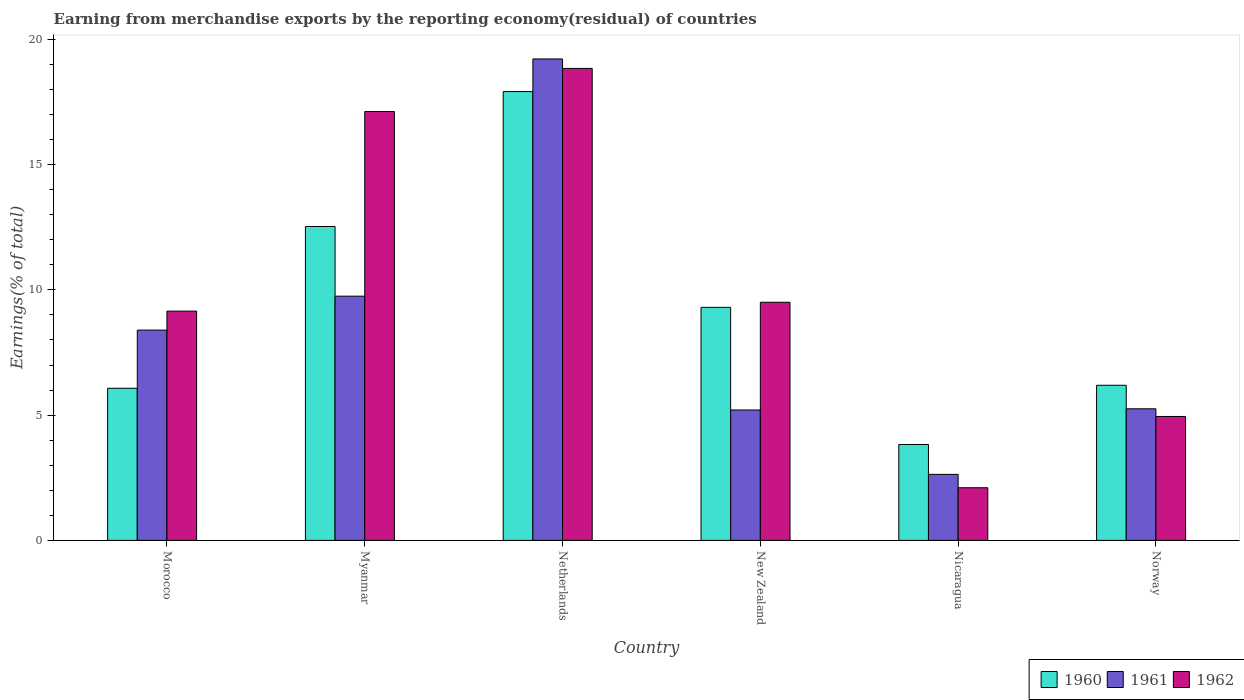How many different coloured bars are there?
Provide a succinct answer. 3. Are the number of bars per tick equal to the number of legend labels?
Make the answer very short. Yes. Are the number of bars on each tick of the X-axis equal?
Provide a succinct answer. Yes. How many bars are there on the 5th tick from the left?
Keep it short and to the point. 3. How many bars are there on the 2nd tick from the right?
Make the answer very short. 3. What is the label of the 2nd group of bars from the left?
Provide a succinct answer. Myanmar. In how many cases, is the number of bars for a given country not equal to the number of legend labels?
Your response must be concise. 0. What is the percentage of amount earned from merchandise exports in 1961 in Nicaragua?
Offer a very short reply. 2.64. Across all countries, what is the maximum percentage of amount earned from merchandise exports in 1960?
Offer a terse response. 17.91. Across all countries, what is the minimum percentage of amount earned from merchandise exports in 1961?
Your answer should be very brief. 2.64. In which country was the percentage of amount earned from merchandise exports in 1961 maximum?
Your answer should be compact. Netherlands. In which country was the percentage of amount earned from merchandise exports in 1960 minimum?
Keep it short and to the point. Nicaragua. What is the total percentage of amount earned from merchandise exports in 1961 in the graph?
Make the answer very short. 50.45. What is the difference between the percentage of amount earned from merchandise exports in 1962 in New Zealand and that in Norway?
Your answer should be compact. 4.56. What is the difference between the percentage of amount earned from merchandise exports in 1962 in Myanmar and the percentage of amount earned from merchandise exports in 1961 in Nicaragua?
Provide a succinct answer. 14.48. What is the average percentage of amount earned from merchandise exports in 1961 per country?
Your answer should be compact. 8.41. What is the difference between the percentage of amount earned from merchandise exports of/in 1960 and percentage of amount earned from merchandise exports of/in 1962 in Netherlands?
Keep it short and to the point. -0.92. In how many countries, is the percentage of amount earned from merchandise exports in 1960 greater than 6 %?
Your answer should be compact. 5. What is the ratio of the percentage of amount earned from merchandise exports in 1962 in Morocco to that in New Zealand?
Make the answer very short. 0.96. What is the difference between the highest and the second highest percentage of amount earned from merchandise exports in 1960?
Your answer should be compact. 5.39. What is the difference between the highest and the lowest percentage of amount earned from merchandise exports in 1961?
Give a very brief answer. 16.58. What does the 2nd bar from the left in Nicaragua represents?
Your answer should be compact. 1961. What does the 3rd bar from the right in Morocco represents?
Your response must be concise. 1960. Is it the case that in every country, the sum of the percentage of amount earned from merchandise exports in 1961 and percentage of amount earned from merchandise exports in 1960 is greater than the percentage of amount earned from merchandise exports in 1962?
Keep it short and to the point. Yes. How many bars are there?
Offer a very short reply. 18. Are all the bars in the graph horizontal?
Make the answer very short. No. What is the difference between two consecutive major ticks on the Y-axis?
Provide a succinct answer. 5. Does the graph contain any zero values?
Your response must be concise. No. Does the graph contain grids?
Your answer should be compact. No. Where does the legend appear in the graph?
Your answer should be compact. Bottom right. How many legend labels are there?
Provide a succinct answer. 3. How are the legend labels stacked?
Offer a very short reply. Horizontal. What is the title of the graph?
Provide a short and direct response. Earning from merchandise exports by the reporting economy(residual) of countries. Does "2000" appear as one of the legend labels in the graph?
Make the answer very short. No. What is the label or title of the Y-axis?
Offer a very short reply. Earnings(% of total). What is the Earnings(% of total) in 1960 in Morocco?
Give a very brief answer. 6.07. What is the Earnings(% of total) of 1961 in Morocco?
Provide a succinct answer. 8.39. What is the Earnings(% of total) in 1962 in Morocco?
Provide a succinct answer. 9.15. What is the Earnings(% of total) of 1960 in Myanmar?
Offer a very short reply. 12.53. What is the Earnings(% of total) in 1961 in Myanmar?
Offer a terse response. 9.75. What is the Earnings(% of total) of 1962 in Myanmar?
Offer a terse response. 17.12. What is the Earnings(% of total) of 1960 in Netherlands?
Give a very brief answer. 17.91. What is the Earnings(% of total) of 1961 in Netherlands?
Offer a very short reply. 19.22. What is the Earnings(% of total) in 1962 in Netherlands?
Your answer should be compact. 18.84. What is the Earnings(% of total) of 1960 in New Zealand?
Give a very brief answer. 9.3. What is the Earnings(% of total) of 1961 in New Zealand?
Your answer should be compact. 5.21. What is the Earnings(% of total) in 1962 in New Zealand?
Offer a terse response. 9.51. What is the Earnings(% of total) in 1960 in Nicaragua?
Your answer should be very brief. 3.83. What is the Earnings(% of total) in 1961 in Nicaragua?
Give a very brief answer. 2.64. What is the Earnings(% of total) in 1962 in Nicaragua?
Make the answer very short. 2.1. What is the Earnings(% of total) in 1960 in Norway?
Offer a very short reply. 6.19. What is the Earnings(% of total) in 1961 in Norway?
Offer a very short reply. 5.25. What is the Earnings(% of total) of 1962 in Norway?
Your response must be concise. 4.95. Across all countries, what is the maximum Earnings(% of total) of 1960?
Your answer should be compact. 17.91. Across all countries, what is the maximum Earnings(% of total) of 1961?
Give a very brief answer. 19.22. Across all countries, what is the maximum Earnings(% of total) of 1962?
Provide a short and direct response. 18.84. Across all countries, what is the minimum Earnings(% of total) of 1960?
Offer a very short reply. 3.83. Across all countries, what is the minimum Earnings(% of total) of 1961?
Offer a terse response. 2.64. Across all countries, what is the minimum Earnings(% of total) of 1962?
Offer a terse response. 2.1. What is the total Earnings(% of total) in 1960 in the graph?
Your answer should be compact. 55.84. What is the total Earnings(% of total) in 1961 in the graph?
Make the answer very short. 50.45. What is the total Earnings(% of total) of 1962 in the graph?
Provide a succinct answer. 61.66. What is the difference between the Earnings(% of total) of 1960 in Morocco and that in Myanmar?
Offer a terse response. -6.46. What is the difference between the Earnings(% of total) of 1961 in Morocco and that in Myanmar?
Provide a succinct answer. -1.35. What is the difference between the Earnings(% of total) of 1962 in Morocco and that in Myanmar?
Offer a terse response. -7.97. What is the difference between the Earnings(% of total) in 1960 in Morocco and that in Netherlands?
Provide a short and direct response. -11.84. What is the difference between the Earnings(% of total) in 1961 in Morocco and that in Netherlands?
Provide a short and direct response. -10.82. What is the difference between the Earnings(% of total) in 1962 in Morocco and that in Netherlands?
Offer a terse response. -9.69. What is the difference between the Earnings(% of total) in 1960 in Morocco and that in New Zealand?
Your response must be concise. -3.23. What is the difference between the Earnings(% of total) in 1961 in Morocco and that in New Zealand?
Ensure brevity in your answer.  3.19. What is the difference between the Earnings(% of total) of 1962 in Morocco and that in New Zealand?
Ensure brevity in your answer.  -0.35. What is the difference between the Earnings(% of total) in 1960 in Morocco and that in Nicaragua?
Make the answer very short. 2.24. What is the difference between the Earnings(% of total) of 1961 in Morocco and that in Nicaragua?
Your answer should be very brief. 5.76. What is the difference between the Earnings(% of total) of 1962 in Morocco and that in Nicaragua?
Your answer should be very brief. 7.05. What is the difference between the Earnings(% of total) in 1960 in Morocco and that in Norway?
Your answer should be very brief. -0.12. What is the difference between the Earnings(% of total) of 1961 in Morocco and that in Norway?
Your answer should be very brief. 3.14. What is the difference between the Earnings(% of total) of 1962 in Morocco and that in Norway?
Offer a terse response. 4.21. What is the difference between the Earnings(% of total) in 1960 in Myanmar and that in Netherlands?
Give a very brief answer. -5.39. What is the difference between the Earnings(% of total) of 1961 in Myanmar and that in Netherlands?
Keep it short and to the point. -9.47. What is the difference between the Earnings(% of total) in 1962 in Myanmar and that in Netherlands?
Offer a very short reply. -1.72. What is the difference between the Earnings(% of total) of 1960 in Myanmar and that in New Zealand?
Give a very brief answer. 3.23. What is the difference between the Earnings(% of total) in 1961 in Myanmar and that in New Zealand?
Provide a short and direct response. 4.54. What is the difference between the Earnings(% of total) of 1962 in Myanmar and that in New Zealand?
Ensure brevity in your answer.  7.61. What is the difference between the Earnings(% of total) in 1960 in Myanmar and that in Nicaragua?
Give a very brief answer. 8.7. What is the difference between the Earnings(% of total) in 1961 in Myanmar and that in Nicaragua?
Ensure brevity in your answer.  7.11. What is the difference between the Earnings(% of total) in 1962 in Myanmar and that in Nicaragua?
Ensure brevity in your answer.  15.02. What is the difference between the Earnings(% of total) of 1960 in Myanmar and that in Norway?
Provide a succinct answer. 6.34. What is the difference between the Earnings(% of total) of 1961 in Myanmar and that in Norway?
Provide a succinct answer. 4.5. What is the difference between the Earnings(% of total) in 1962 in Myanmar and that in Norway?
Keep it short and to the point. 12.17. What is the difference between the Earnings(% of total) of 1960 in Netherlands and that in New Zealand?
Provide a short and direct response. 8.61. What is the difference between the Earnings(% of total) of 1961 in Netherlands and that in New Zealand?
Offer a very short reply. 14.01. What is the difference between the Earnings(% of total) in 1962 in Netherlands and that in New Zealand?
Make the answer very short. 9.33. What is the difference between the Earnings(% of total) in 1960 in Netherlands and that in Nicaragua?
Your answer should be very brief. 14.09. What is the difference between the Earnings(% of total) of 1961 in Netherlands and that in Nicaragua?
Ensure brevity in your answer.  16.58. What is the difference between the Earnings(% of total) in 1962 in Netherlands and that in Nicaragua?
Your answer should be very brief. 16.74. What is the difference between the Earnings(% of total) in 1960 in Netherlands and that in Norway?
Your answer should be compact. 11.72. What is the difference between the Earnings(% of total) of 1961 in Netherlands and that in Norway?
Your response must be concise. 13.96. What is the difference between the Earnings(% of total) of 1962 in Netherlands and that in Norway?
Provide a succinct answer. 13.89. What is the difference between the Earnings(% of total) of 1960 in New Zealand and that in Nicaragua?
Give a very brief answer. 5.48. What is the difference between the Earnings(% of total) of 1961 in New Zealand and that in Nicaragua?
Your answer should be very brief. 2.57. What is the difference between the Earnings(% of total) of 1962 in New Zealand and that in Nicaragua?
Give a very brief answer. 7.4. What is the difference between the Earnings(% of total) of 1960 in New Zealand and that in Norway?
Give a very brief answer. 3.11. What is the difference between the Earnings(% of total) of 1961 in New Zealand and that in Norway?
Your answer should be compact. -0.05. What is the difference between the Earnings(% of total) of 1962 in New Zealand and that in Norway?
Your answer should be very brief. 4.56. What is the difference between the Earnings(% of total) in 1960 in Nicaragua and that in Norway?
Ensure brevity in your answer.  -2.36. What is the difference between the Earnings(% of total) of 1961 in Nicaragua and that in Norway?
Provide a succinct answer. -2.62. What is the difference between the Earnings(% of total) of 1962 in Nicaragua and that in Norway?
Provide a succinct answer. -2.84. What is the difference between the Earnings(% of total) in 1960 in Morocco and the Earnings(% of total) in 1961 in Myanmar?
Keep it short and to the point. -3.68. What is the difference between the Earnings(% of total) in 1960 in Morocco and the Earnings(% of total) in 1962 in Myanmar?
Provide a short and direct response. -11.05. What is the difference between the Earnings(% of total) of 1961 in Morocco and the Earnings(% of total) of 1962 in Myanmar?
Ensure brevity in your answer.  -8.72. What is the difference between the Earnings(% of total) in 1960 in Morocco and the Earnings(% of total) in 1961 in Netherlands?
Ensure brevity in your answer.  -13.14. What is the difference between the Earnings(% of total) in 1960 in Morocco and the Earnings(% of total) in 1962 in Netherlands?
Keep it short and to the point. -12.77. What is the difference between the Earnings(% of total) of 1961 in Morocco and the Earnings(% of total) of 1962 in Netherlands?
Your answer should be compact. -10.45. What is the difference between the Earnings(% of total) of 1960 in Morocco and the Earnings(% of total) of 1961 in New Zealand?
Your answer should be compact. 0.87. What is the difference between the Earnings(% of total) of 1960 in Morocco and the Earnings(% of total) of 1962 in New Zealand?
Your response must be concise. -3.43. What is the difference between the Earnings(% of total) in 1961 in Morocco and the Earnings(% of total) in 1962 in New Zealand?
Give a very brief answer. -1.11. What is the difference between the Earnings(% of total) in 1960 in Morocco and the Earnings(% of total) in 1961 in Nicaragua?
Your response must be concise. 3.44. What is the difference between the Earnings(% of total) of 1960 in Morocco and the Earnings(% of total) of 1962 in Nicaragua?
Your response must be concise. 3.97. What is the difference between the Earnings(% of total) of 1961 in Morocco and the Earnings(% of total) of 1962 in Nicaragua?
Your answer should be very brief. 6.29. What is the difference between the Earnings(% of total) in 1960 in Morocco and the Earnings(% of total) in 1961 in Norway?
Offer a very short reply. 0.82. What is the difference between the Earnings(% of total) of 1960 in Morocco and the Earnings(% of total) of 1962 in Norway?
Your answer should be compact. 1.13. What is the difference between the Earnings(% of total) of 1961 in Morocco and the Earnings(% of total) of 1962 in Norway?
Ensure brevity in your answer.  3.45. What is the difference between the Earnings(% of total) in 1960 in Myanmar and the Earnings(% of total) in 1961 in Netherlands?
Give a very brief answer. -6.69. What is the difference between the Earnings(% of total) in 1960 in Myanmar and the Earnings(% of total) in 1962 in Netherlands?
Keep it short and to the point. -6.31. What is the difference between the Earnings(% of total) of 1961 in Myanmar and the Earnings(% of total) of 1962 in Netherlands?
Offer a very short reply. -9.09. What is the difference between the Earnings(% of total) in 1960 in Myanmar and the Earnings(% of total) in 1961 in New Zealand?
Give a very brief answer. 7.32. What is the difference between the Earnings(% of total) of 1960 in Myanmar and the Earnings(% of total) of 1962 in New Zealand?
Ensure brevity in your answer.  3.02. What is the difference between the Earnings(% of total) of 1961 in Myanmar and the Earnings(% of total) of 1962 in New Zealand?
Your answer should be very brief. 0.24. What is the difference between the Earnings(% of total) of 1960 in Myanmar and the Earnings(% of total) of 1961 in Nicaragua?
Ensure brevity in your answer.  9.89. What is the difference between the Earnings(% of total) of 1960 in Myanmar and the Earnings(% of total) of 1962 in Nicaragua?
Ensure brevity in your answer.  10.43. What is the difference between the Earnings(% of total) of 1961 in Myanmar and the Earnings(% of total) of 1962 in Nicaragua?
Make the answer very short. 7.65. What is the difference between the Earnings(% of total) of 1960 in Myanmar and the Earnings(% of total) of 1961 in Norway?
Keep it short and to the point. 7.28. What is the difference between the Earnings(% of total) of 1960 in Myanmar and the Earnings(% of total) of 1962 in Norway?
Ensure brevity in your answer.  7.58. What is the difference between the Earnings(% of total) of 1961 in Myanmar and the Earnings(% of total) of 1962 in Norway?
Provide a succinct answer. 4.8. What is the difference between the Earnings(% of total) in 1960 in Netherlands and the Earnings(% of total) in 1961 in New Zealand?
Keep it short and to the point. 12.71. What is the difference between the Earnings(% of total) in 1960 in Netherlands and the Earnings(% of total) in 1962 in New Zealand?
Offer a terse response. 8.41. What is the difference between the Earnings(% of total) of 1961 in Netherlands and the Earnings(% of total) of 1962 in New Zealand?
Keep it short and to the point. 9.71. What is the difference between the Earnings(% of total) in 1960 in Netherlands and the Earnings(% of total) in 1961 in Nicaragua?
Your answer should be very brief. 15.28. What is the difference between the Earnings(% of total) in 1960 in Netherlands and the Earnings(% of total) in 1962 in Nicaragua?
Provide a short and direct response. 15.81. What is the difference between the Earnings(% of total) of 1961 in Netherlands and the Earnings(% of total) of 1962 in Nicaragua?
Provide a short and direct response. 17.12. What is the difference between the Earnings(% of total) in 1960 in Netherlands and the Earnings(% of total) in 1961 in Norway?
Provide a short and direct response. 12.66. What is the difference between the Earnings(% of total) in 1960 in Netherlands and the Earnings(% of total) in 1962 in Norway?
Your answer should be very brief. 12.97. What is the difference between the Earnings(% of total) of 1961 in Netherlands and the Earnings(% of total) of 1962 in Norway?
Provide a succinct answer. 14.27. What is the difference between the Earnings(% of total) of 1960 in New Zealand and the Earnings(% of total) of 1961 in Nicaragua?
Offer a terse response. 6.67. What is the difference between the Earnings(% of total) of 1960 in New Zealand and the Earnings(% of total) of 1962 in Nicaragua?
Keep it short and to the point. 7.2. What is the difference between the Earnings(% of total) of 1961 in New Zealand and the Earnings(% of total) of 1962 in Nicaragua?
Your response must be concise. 3.1. What is the difference between the Earnings(% of total) in 1960 in New Zealand and the Earnings(% of total) in 1961 in Norway?
Offer a terse response. 4.05. What is the difference between the Earnings(% of total) of 1960 in New Zealand and the Earnings(% of total) of 1962 in Norway?
Provide a succinct answer. 4.36. What is the difference between the Earnings(% of total) in 1961 in New Zealand and the Earnings(% of total) in 1962 in Norway?
Give a very brief answer. 0.26. What is the difference between the Earnings(% of total) in 1960 in Nicaragua and the Earnings(% of total) in 1961 in Norway?
Make the answer very short. -1.42. What is the difference between the Earnings(% of total) in 1960 in Nicaragua and the Earnings(% of total) in 1962 in Norway?
Offer a terse response. -1.12. What is the difference between the Earnings(% of total) in 1961 in Nicaragua and the Earnings(% of total) in 1962 in Norway?
Provide a short and direct response. -2.31. What is the average Earnings(% of total) of 1960 per country?
Your answer should be compact. 9.31. What is the average Earnings(% of total) in 1961 per country?
Provide a succinct answer. 8.41. What is the average Earnings(% of total) in 1962 per country?
Make the answer very short. 10.28. What is the difference between the Earnings(% of total) in 1960 and Earnings(% of total) in 1961 in Morocco?
Provide a succinct answer. -2.32. What is the difference between the Earnings(% of total) of 1960 and Earnings(% of total) of 1962 in Morocco?
Your response must be concise. -3.08. What is the difference between the Earnings(% of total) in 1961 and Earnings(% of total) in 1962 in Morocco?
Offer a terse response. -0.76. What is the difference between the Earnings(% of total) of 1960 and Earnings(% of total) of 1961 in Myanmar?
Provide a succinct answer. 2.78. What is the difference between the Earnings(% of total) of 1960 and Earnings(% of total) of 1962 in Myanmar?
Provide a succinct answer. -4.59. What is the difference between the Earnings(% of total) in 1961 and Earnings(% of total) in 1962 in Myanmar?
Provide a short and direct response. -7.37. What is the difference between the Earnings(% of total) in 1960 and Earnings(% of total) in 1961 in Netherlands?
Your answer should be compact. -1.3. What is the difference between the Earnings(% of total) in 1960 and Earnings(% of total) in 1962 in Netherlands?
Offer a very short reply. -0.92. What is the difference between the Earnings(% of total) in 1961 and Earnings(% of total) in 1962 in Netherlands?
Keep it short and to the point. 0.38. What is the difference between the Earnings(% of total) in 1960 and Earnings(% of total) in 1961 in New Zealand?
Your response must be concise. 4.1. What is the difference between the Earnings(% of total) in 1960 and Earnings(% of total) in 1962 in New Zealand?
Ensure brevity in your answer.  -0.2. What is the difference between the Earnings(% of total) in 1961 and Earnings(% of total) in 1962 in New Zealand?
Provide a short and direct response. -4.3. What is the difference between the Earnings(% of total) in 1960 and Earnings(% of total) in 1961 in Nicaragua?
Make the answer very short. 1.19. What is the difference between the Earnings(% of total) in 1960 and Earnings(% of total) in 1962 in Nicaragua?
Your response must be concise. 1.73. What is the difference between the Earnings(% of total) in 1961 and Earnings(% of total) in 1962 in Nicaragua?
Keep it short and to the point. 0.53. What is the difference between the Earnings(% of total) of 1960 and Earnings(% of total) of 1961 in Norway?
Your answer should be compact. 0.94. What is the difference between the Earnings(% of total) in 1960 and Earnings(% of total) in 1962 in Norway?
Make the answer very short. 1.25. What is the difference between the Earnings(% of total) of 1961 and Earnings(% of total) of 1962 in Norway?
Ensure brevity in your answer.  0.31. What is the ratio of the Earnings(% of total) in 1960 in Morocco to that in Myanmar?
Make the answer very short. 0.48. What is the ratio of the Earnings(% of total) in 1961 in Morocco to that in Myanmar?
Your response must be concise. 0.86. What is the ratio of the Earnings(% of total) in 1962 in Morocco to that in Myanmar?
Offer a very short reply. 0.53. What is the ratio of the Earnings(% of total) in 1960 in Morocco to that in Netherlands?
Provide a succinct answer. 0.34. What is the ratio of the Earnings(% of total) of 1961 in Morocco to that in Netherlands?
Your answer should be compact. 0.44. What is the ratio of the Earnings(% of total) in 1962 in Morocco to that in Netherlands?
Provide a short and direct response. 0.49. What is the ratio of the Earnings(% of total) in 1960 in Morocco to that in New Zealand?
Your response must be concise. 0.65. What is the ratio of the Earnings(% of total) in 1961 in Morocco to that in New Zealand?
Your answer should be compact. 1.61. What is the ratio of the Earnings(% of total) of 1962 in Morocco to that in New Zealand?
Make the answer very short. 0.96. What is the ratio of the Earnings(% of total) of 1960 in Morocco to that in Nicaragua?
Ensure brevity in your answer.  1.59. What is the ratio of the Earnings(% of total) in 1961 in Morocco to that in Nicaragua?
Provide a short and direct response. 3.19. What is the ratio of the Earnings(% of total) in 1962 in Morocco to that in Nicaragua?
Ensure brevity in your answer.  4.35. What is the ratio of the Earnings(% of total) in 1960 in Morocco to that in Norway?
Your answer should be very brief. 0.98. What is the ratio of the Earnings(% of total) in 1961 in Morocco to that in Norway?
Make the answer very short. 1.6. What is the ratio of the Earnings(% of total) of 1962 in Morocco to that in Norway?
Your answer should be very brief. 1.85. What is the ratio of the Earnings(% of total) in 1960 in Myanmar to that in Netherlands?
Provide a short and direct response. 0.7. What is the ratio of the Earnings(% of total) in 1961 in Myanmar to that in Netherlands?
Make the answer very short. 0.51. What is the ratio of the Earnings(% of total) of 1962 in Myanmar to that in Netherlands?
Make the answer very short. 0.91. What is the ratio of the Earnings(% of total) in 1960 in Myanmar to that in New Zealand?
Keep it short and to the point. 1.35. What is the ratio of the Earnings(% of total) of 1961 in Myanmar to that in New Zealand?
Keep it short and to the point. 1.87. What is the ratio of the Earnings(% of total) of 1962 in Myanmar to that in New Zealand?
Provide a short and direct response. 1.8. What is the ratio of the Earnings(% of total) of 1960 in Myanmar to that in Nicaragua?
Offer a terse response. 3.27. What is the ratio of the Earnings(% of total) of 1961 in Myanmar to that in Nicaragua?
Offer a terse response. 3.7. What is the ratio of the Earnings(% of total) in 1962 in Myanmar to that in Nicaragua?
Offer a very short reply. 8.14. What is the ratio of the Earnings(% of total) in 1960 in Myanmar to that in Norway?
Provide a succinct answer. 2.02. What is the ratio of the Earnings(% of total) of 1961 in Myanmar to that in Norway?
Provide a succinct answer. 1.86. What is the ratio of the Earnings(% of total) in 1962 in Myanmar to that in Norway?
Ensure brevity in your answer.  3.46. What is the ratio of the Earnings(% of total) of 1960 in Netherlands to that in New Zealand?
Give a very brief answer. 1.93. What is the ratio of the Earnings(% of total) in 1961 in Netherlands to that in New Zealand?
Your response must be concise. 3.69. What is the ratio of the Earnings(% of total) in 1962 in Netherlands to that in New Zealand?
Provide a succinct answer. 1.98. What is the ratio of the Earnings(% of total) in 1960 in Netherlands to that in Nicaragua?
Provide a short and direct response. 4.68. What is the ratio of the Earnings(% of total) of 1961 in Netherlands to that in Nicaragua?
Provide a short and direct response. 7.29. What is the ratio of the Earnings(% of total) in 1962 in Netherlands to that in Nicaragua?
Give a very brief answer. 8.96. What is the ratio of the Earnings(% of total) in 1960 in Netherlands to that in Norway?
Your answer should be very brief. 2.89. What is the ratio of the Earnings(% of total) of 1961 in Netherlands to that in Norway?
Provide a succinct answer. 3.66. What is the ratio of the Earnings(% of total) in 1962 in Netherlands to that in Norway?
Ensure brevity in your answer.  3.81. What is the ratio of the Earnings(% of total) of 1960 in New Zealand to that in Nicaragua?
Provide a short and direct response. 2.43. What is the ratio of the Earnings(% of total) in 1961 in New Zealand to that in Nicaragua?
Your response must be concise. 1.98. What is the ratio of the Earnings(% of total) in 1962 in New Zealand to that in Nicaragua?
Provide a succinct answer. 4.52. What is the ratio of the Earnings(% of total) of 1960 in New Zealand to that in Norway?
Offer a very short reply. 1.5. What is the ratio of the Earnings(% of total) in 1961 in New Zealand to that in Norway?
Your answer should be compact. 0.99. What is the ratio of the Earnings(% of total) in 1962 in New Zealand to that in Norway?
Your answer should be very brief. 1.92. What is the ratio of the Earnings(% of total) of 1960 in Nicaragua to that in Norway?
Provide a succinct answer. 0.62. What is the ratio of the Earnings(% of total) in 1961 in Nicaragua to that in Norway?
Offer a very short reply. 0.5. What is the ratio of the Earnings(% of total) in 1962 in Nicaragua to that in Norway?
Give a very brief answer. 0.42. What is the difference between the highest and the second highest Earnings(% of total) of 1960?
Give a very brief answer. 5.39. What is the difference between the highest and the second highest Earnings(% of total) of 1961?
Make the answer very short. 9.47. What is the difference between the highest and the second highest Earnings(% of total) in 1962?
Provide a succinct answer. 1.72. What is the difference between the highest and the lowest Earnings(% of total) in 1960?
Make the answer very short. 14.09. What is the difference between the highest and the lowest Earnings(% of total) of 1961?
Make the answer very short. 16.58. What is the difference between the highest and the lowest Earnings(% of total) of 1962?
Give a very brief answer. 16.74. 